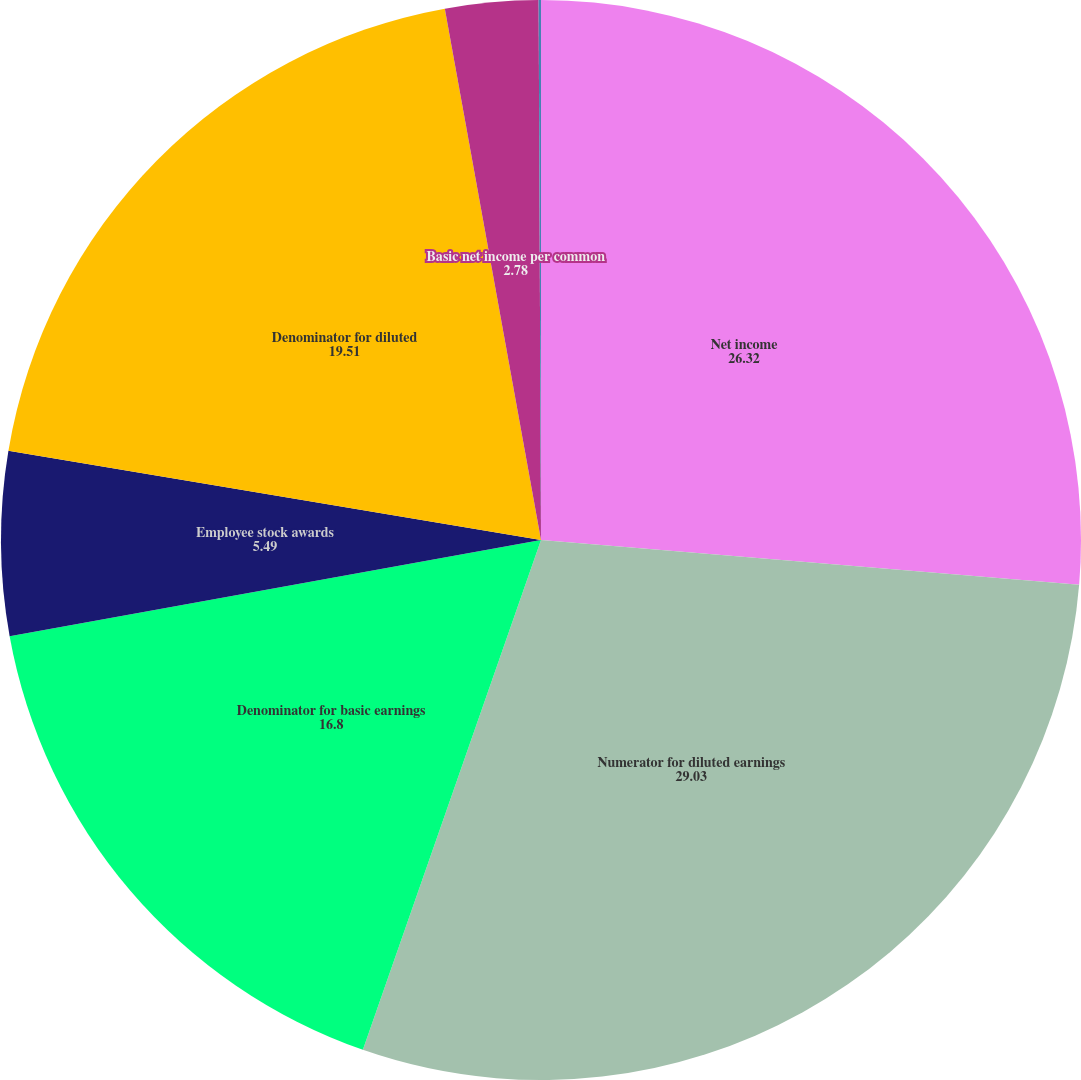Convert chart. <chart><loc_0><loc_0><loc_500><loc_500><pie_chart><fcel>Net income<fcel>Numerator for diluted earnings<fcel>Denominator for basic earnings<fcel>Employee stock awards<fcel>Denominator for diluted<fcel>Basic net income per common<fcel>Net income per common share<nl><fcel>26.32%<fcel>29.03%<fcel>16.8%<fcel>5.49%<fcel>19.51%<fcel>2.78%<fcel>0.07%<nl></chart> 